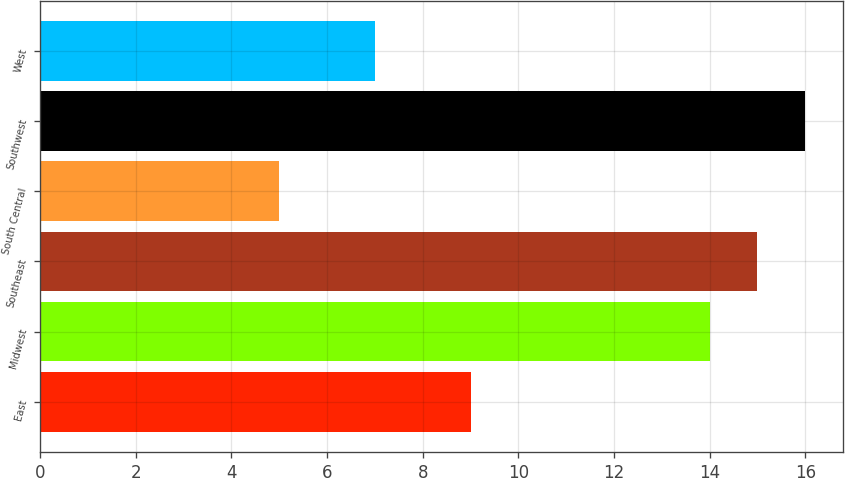Convert chart. <chart><loc_0><loc_0><loc_500><loc_500><bar_chart><fcel>East<fcel>Midwest<fcel>Southeast<fcel>South Central<fcel>Southwest<fcel>West<nl><fcel>9<fcel>14<fcel>15<fcel>5<fcel>16<fcel>7<nl></chart> 